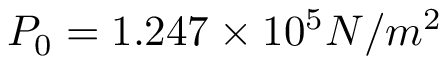Convert formula to latex. <formula><loc_0><loc_0><loc_500><loc_500>P _ { 0 } = 1 . 2 4 7 \times 1 0 ^ { 5 } N / m ^ { 2 }</formula> 